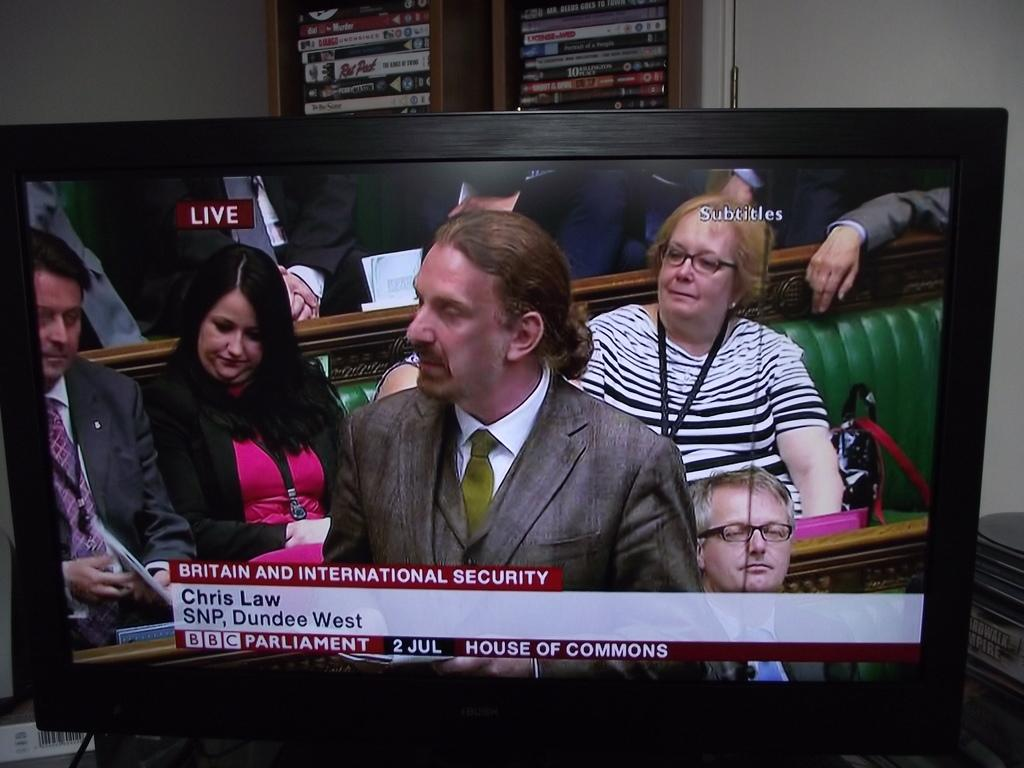<image>
Provide a brief description of the given image. a man named Chris talks on the tv 